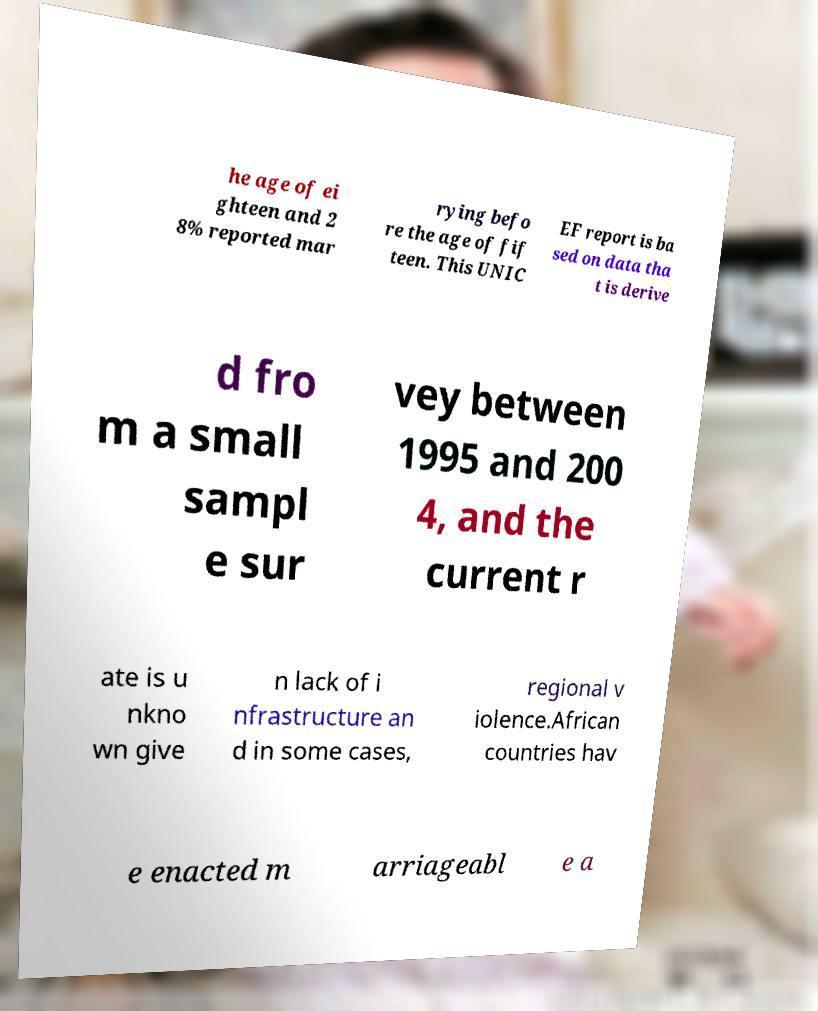Please identify and transcribe the text found in this image. he age of ei ghteen and 2 8% reported mar rying befo re the age of fif teen. This UNIC EF report is ba sed on data tha t is derive d fro m a small sampl e sur vey between 1995 and 200 4, and the current r ate is u nkno wn give n lack of i nfrastructure an d in some cases, regional v iolence.African countries hav e enacted m arriageabl e a 